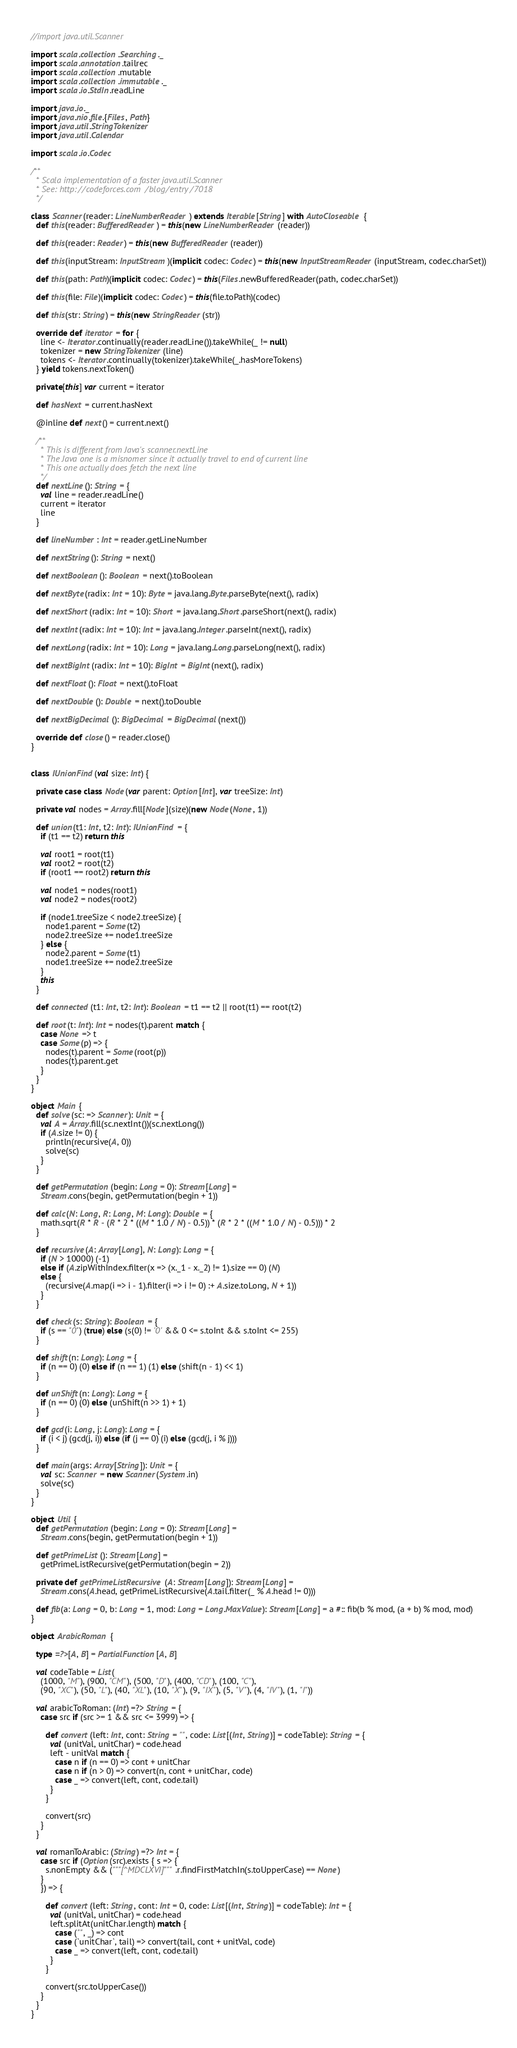Convert code to text. <code><loc_0><loc_0><loc_500><loc_500><_Scala_>//import java.util.Scanner

import scala.collection.Searching._
import scala.annotation.tailrec
import scala.collection.mutable
import scala.collection.immutable._
import scala.io.StdIn.readLine

import java.io._
import java.nio.file.{Files, Path}
import java.util.StringTokenizer
import java.util.Calendar

import scala.io.Codec

/**
  * Scala implementation of a faster java.util.Scanner
  * See: http://codeforces.com/blog/entry/7018
  */

class Scanner(reader: LineNumberReader) extends Iterable[String] with AutoCloseable {
  def this(reader: BufferedReader) = this(new LineNumberReader(reader))

  def this(reader: Reader) = this(new BufferedReader(reader))

  def this(inputStream: InputStream)(implicit codec: Codec) = this(new InputStreamReader(inputStream, codec.charSet))

  def this(path: Path)(implicit codec: Codec) = this(Files.newBufferedReader(path, codec.charSet))

  def this(file: File)(implicit codec: Codec) = this(file.toPath)(codec)

  def this(str: String) = this(new StringReader(str))

  override def iterator = for {
    line <- Iterator.continually(reader.readLine()).takeWhile(_ != null)
    tokenizer = new StringTokenizer(line)
    tokens <- Iterator.continually(tokenizer).takeWhile(_.hasMoreTokens)
  } yield tokens.nextToken()

  private[this] var current = iterator

  def hasNext = current.hasNext

  @inline def next() = current.next()

  /**
    * This is different from Java's scanner.nextLine
    * The Java one is a misnomer since it actually travel to end of current line
    * This one actually does fetch the next line
    */
  def nextLine(): String = {
    val line = reader.readLine()
    current = iterator
    line
  }

  def lineNumber: Int = reader.getLineNumber

  def nextString(): String = next()

  def nextBoolean(): Boolean = next().toBoolean

  def nextByte(radix: Int = 10): Byte = java.lang.Byte.parseByte(next(), radix)

  def nextShort(radix: Int = 10): Short = java.lang.Short.parseShort(next(), radix)

  def nextInt(radix: Int = 10): Int = java.lang.Integer.parseInt(next(), radix)

  def nextLong(radix: Int = 10): Long = java.lang.Long.parseLong(next(), radix)

  def nextBigInt(radix: Int = 10): BigInt = BigInt(next(), radix)

  def nextFloat(): Float = next().toFloat

  def nextDouble(): Double = next().toDouble

  def nextBigDecimal(): BigDecimal = BigDecimal(next())

  override def close() = reader.close()
}


class IUnionFind(val size: Int) {

  private case class Node(var parent: Option[Int], var treeSize: Int)

  private val nodes = Array.fill[Node](size)(new Node(None, 1))

  def union(t1: Int, t2: Int): IUnionFind = {
    if (t1 == t2) return this

    val root1 = root(t1)
    val root2 = root(t2)
    if (root1 == root2) return this

    val node1 = nodes(root1)
    val node2 = nodes(root2)

    if (node1.treeSize < node2.treeSize) {
      node1.parent = Some(t2)
      node2.treeSize += node1.treeSize
    } else {
      node2.parent = Some(t1)
      node1.treeSize += node2.treeSize
    }
    this
  }

  def connected(t1: Int, t2: Int): Boolean = t1 == t2 || root(t1) == root(t2)

  def root(t: Int): Int = nodes(t).parent match {
    case None => t
    case Some(p) => {
      nodes(t).parent = Some(root(p))
      nodes(t).parent.get
    }
  }
}

object Main {
  def solve(sc: => Scanner): Unit = {
    val A = Array.fill(sc.nextInt())(sc.nextLong())
    if (A.size != 0) {
      println(recursive(A, 0))
      solve(sc)
    }
  }

  def getPermutation(begin: Long = 0): Stream[Long] =
    Stream.cons(begin, getPermutation(begin + 1))

  def calc(N: Long, R: Long, M: Long): Double = {
    math.sqrt(R * R - (R * 2 * ((M * 1.0 / N) - 0.5)) * (R * 2 * ((M * 1.0 / N) - 0.5))) * 2
  }

  def recursive(A: Array[Long], N: Long): Long = {
    if (N > 10000) (-1)
    else if (A.zipWithIndex.filter(x => (x._1 - x._2) != 1).size == 0) (N)
    else {
      (recursive(A.map(i => i - 1).filter(i => i != 0) :+ A.size.toLong, N + 1))
    }
  }

  def check(s: String): Boolean = {
    if (s == "0") (true) else (s(0) != '0' && 0 <= s.toInt && s.toInt <= 255)
  }

  def shift(n: Long): Long = {
    if (n == 0) (0) else if (n == 1) (1) else (shift(n - 1) << 1)
  }

  def unShift(n: Long): Long = {
    if (n == 0) (0) else (unShift(n >> 1) + 1)
  }

  def gcd(i: Long, j: Long): Long = {
    if (i < j) (gcd(j, i)) else (if (j == 0) (i) else (gcd(j, i % j)))
  }

  def main(args: Array[String]): Unit = {
    val sc: Scanner = new Scanner(System.in)
    solve(sc)
  }
}

object Util {
  def getPermutation(begin: Long = 0): Stream[Long] =
    Stream.cons(begin, getPermutation(begin + 1))

  def getPrimeList(): Stream[Long] =
    getPrimeListRecursive(getPermutation(begin = 2))

  private def getPrimeListRecursive(A: Stream[Long]): Stream[Long] =
    Stream.cons(A.head, getPrimeListRecursive(A.tail.filter(_ % A.head != 0)))

  def fib(a: Long = 0, b: Long = 1, mod: Long = Long.MaxValue): Stream[Long] = a #:: fib(b % mod, (a + b) % mod, mod)
}

object ArabicRoman {

  type =?>[A, B] = PartialFunction[A, B]

  val codeTable = List(
    (1000, "M"), (900, "CM"), (500, "D"), (400, "CD"), (100, "C"),
    (90, "XC"), (50, "L"), (40, "XL"), (10, "X"), (9, "IX"), (5, "V"), (4, "IV"), (1, "I"))

  val arabicToRoman: (Int) =?> String = {
    case src if (src >= 1 && src <= 3999) => {

      def convert(left: Int, cont: String = "", code: List[(Int, String)] = codeTable): String = {
        val (unitVal, unitChar) = code.head
        left - unitVal match {
          case n if (n == 0) => cont + unitChar
          case n if (n > 0) => convert(n, cont + unitChar, code)
          case _ => convert(left, cont, code.tail)
        }
      }

      convert(src)
    }
  }

  val romanToArabic: (String) =?> Int = {
    case src if (Option(src).exists { s => {
      s.nonEmpty && ("""[^MDCLXVI]""".r.findFirstMatchIn(s.toUpperCase) == None)
    }
    }) => {

      def convert(left: String, cont: Int = 0, code: List[(Int, String)] = codeTable): Int = {
        val (unitVal, unitChar) = code.head
        left.splitAt(unitChar.length) match {
          case ("", _) => cont
          case (`unitChar`, tail) => convert(tail, cont + unitVal, code)
          case _ => convert(left, cont, code.tail)
        }
      }

      convert(src.toUpperCase())
    }
  }
}

</code> 